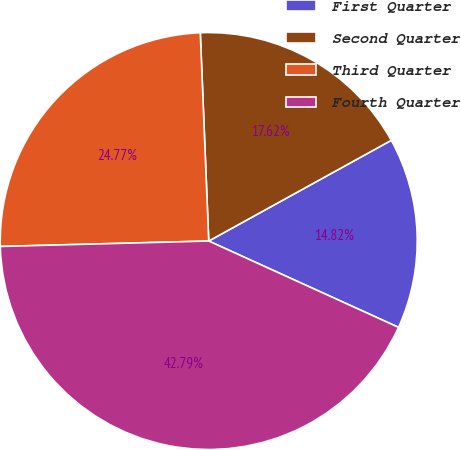Convert chart. <chart><loc_0><loc_0><loc_500><loc_500><pie_chart><fcel>First Quarter<fcel>Second Quarter<fcel>Third Quarter<fcel>Fourth Quarter<nl><fcel>14.82%<fcel>17.62%<fcel>24.77%<fcel>42.79%<nl></chart> 